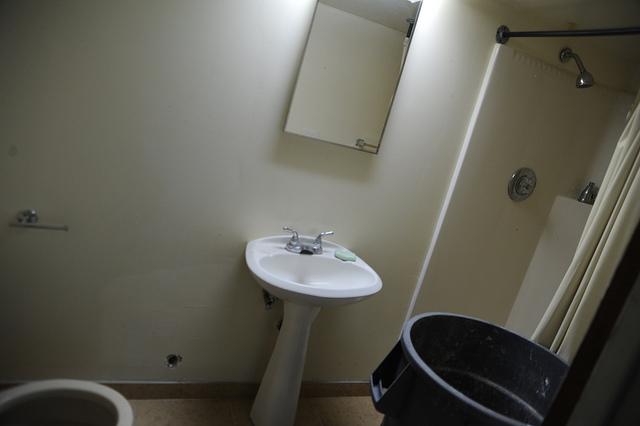Is there a mirror in this picture?
Quick response, please. Yes. What is the sink made of?
Quick response, please. Porcelain. Where is the large trash can?
Write a very short answer. In bathroom. What is this room for?
Write a very short answer. Bathroom. 